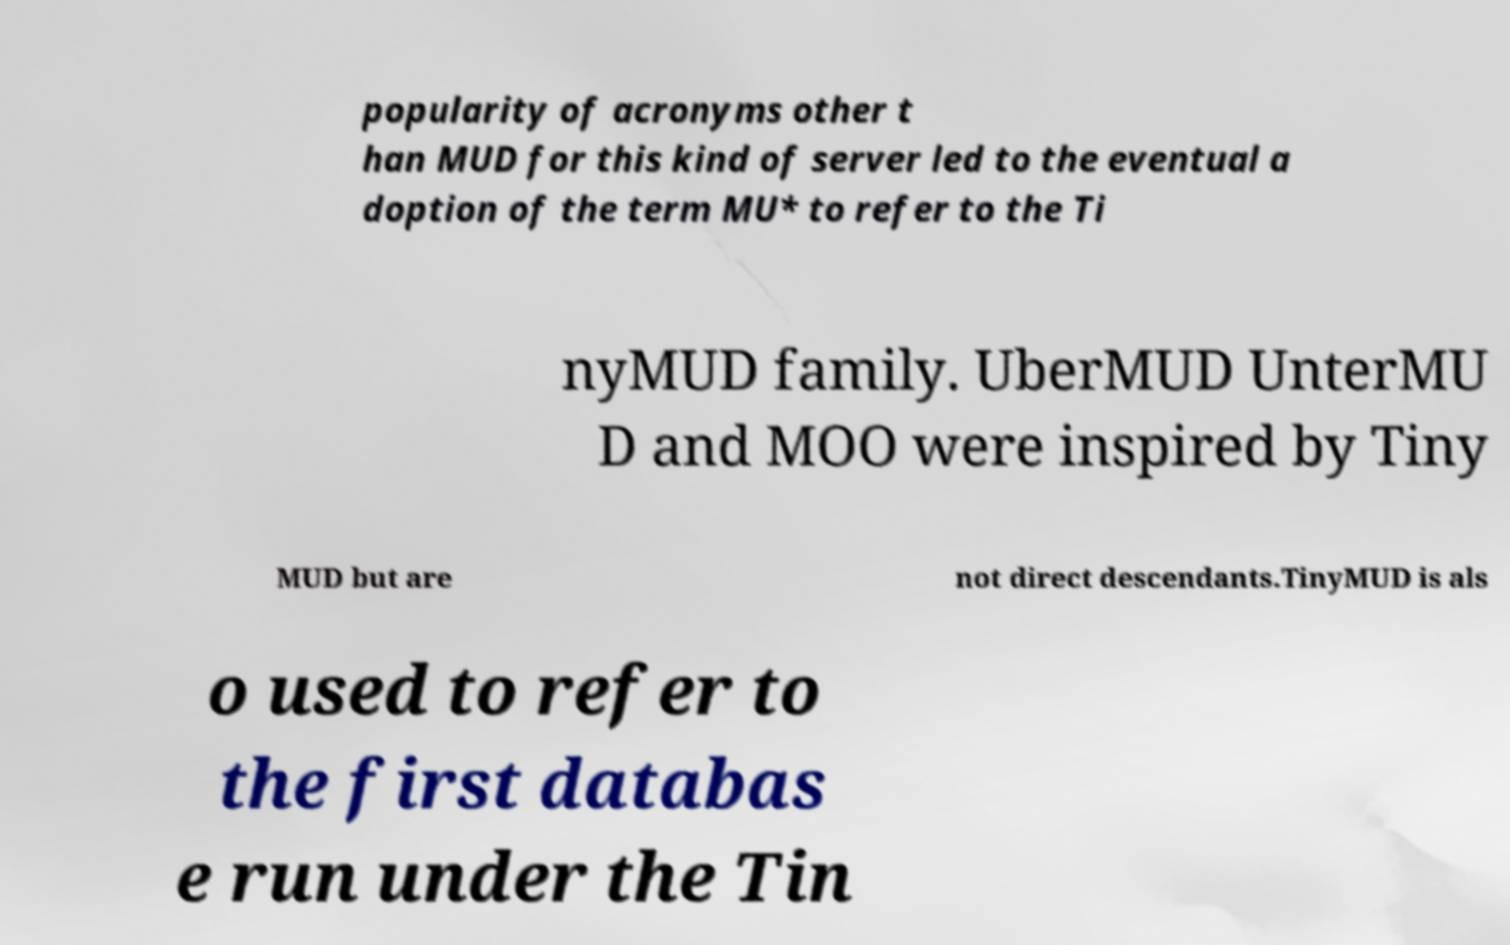Please read and relay the text visible in this image. What does it say? popularity of acronyms other t han MUD for this kind of server led to the eventual a doption of the term MU* to refer to the Ti nyMUD family. UberMUD UnterMU D and MOO were inspired by Tiny MUD but are not direct descendants.TinyMUD is als o used to refer to the first databas e run under the Tin 